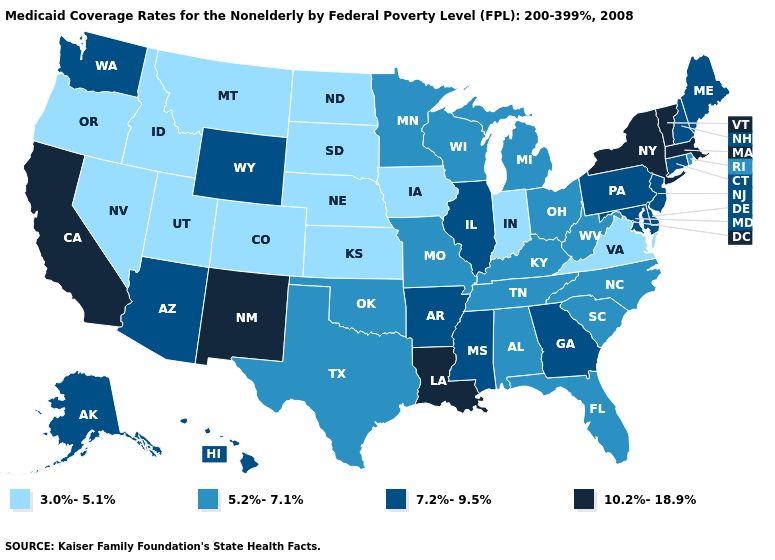What is the value of North Carolina?
Keep it brief. 5.2%-7.1%. What is the value of Mississippi?
Answer briefly. 7.2%-9.5%. What is the highest value in the USA?
Short answer required. 10.2%-18.9%. How many symbols are there in the legend?
Quick response, please. 4. Does the map have missing data?
Give a very brief answer. No. Among the states that border Montana , which have the lowest value?
Write a very short answer. Idaho, North Dakota, South Dakota. What is the highest value in the MidWest ?
Concise answer only. 7.2%-9.5%. Does the first symbol in the legend represent the smallest category?
Short answer required. Yes. How many symbols are there in the legend?
Write a very short answer. 4. Which states have the highest value in the USA?
Short answer required. California, Louisiana, Massachusetts, New Mexico, New York, Vermont. Which states have the lowest value in the USA?
Short answer required. Colorado, Idaho, Indiana, Iowa, Kansas, Montana, Nebraska, Nevada, North Dakota, Oregon, South Dakota, Utah, Virginia. What is the value of Montana?
Give a very brief answer. 3.0%-5.1%. What is the lowest value in the Northeast?
Keep it brief. 5.2%-7.1%. How many symbols are there in the legend?
Be succinct. 4. What is the highest value in the USA?
Write a very short answer. 10.2%-18.9%. 